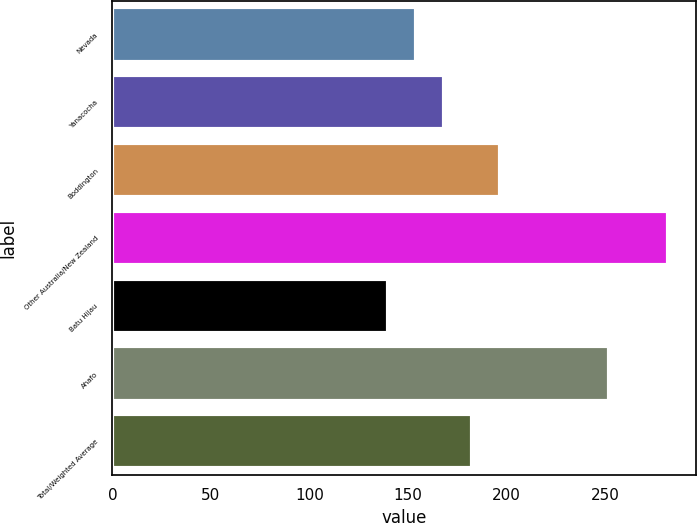<chart> <loc_0><loc_0><loc_500><loc_500><bar_chart><fcel>Nevada<fcel>Yanacocha<fcel>Boddington<fcel>Other Australia/New Zealand<fcel>Batu Hijau<fcel>Ahafo<fcel>Total/Weighted Average<nl><fcel>154.2<fcel>168.4<fcel>196.8<fcel>282<fcel>140<fcel>252<fcel>182.6<nl></chart> 